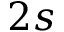<formula> <loc_0><loc_0><loc_500><loc_500>2 s</formula> 